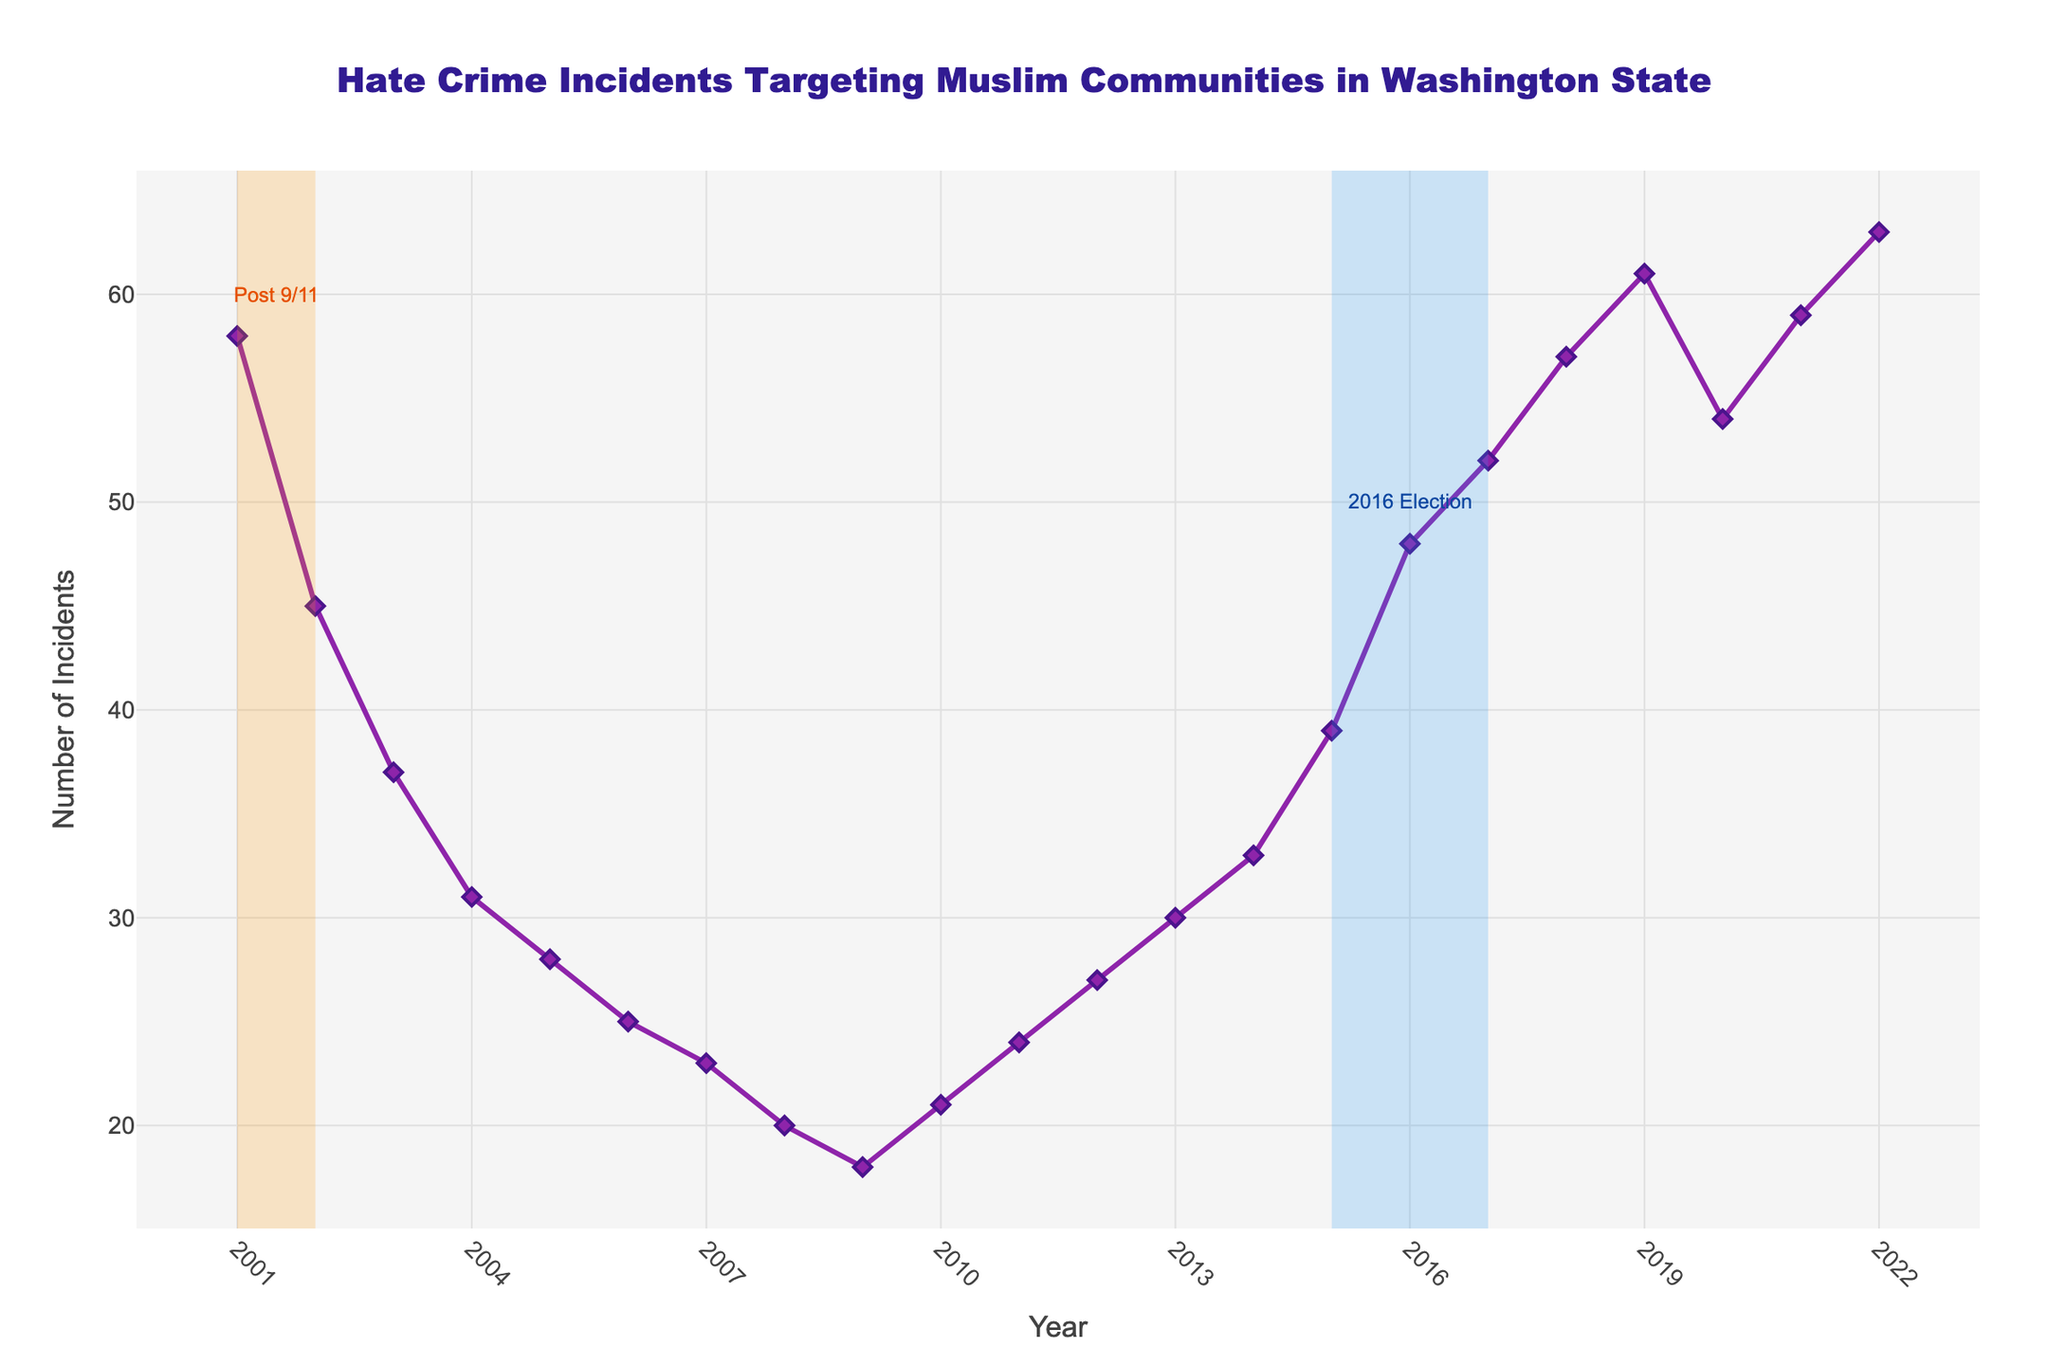Which year had the highest number of hate crime incidents targeting Muslim communities in Washington State? The highest number of hate crime incidents can be found by locating the peak point on the line chart. The peak is at the year 2022 with 63 incidents.
Answer: 2022 How did the number of hate crime incidents change from 2001 to 2003? From 2001 to 2003, the number of incidents decreased. Specifically, it went from 58 in 2001 to 45 in 2002, and then to 37 in 2003.
Answer: Decreased What was the trend in hate crime incidents targeting Muslim communities between 2005 and 2010? Reviewing the chart from 2005 to 2010, the incidents generally showed a decreasing trend initially from 28 in 2005 to 18 in 2009 but increased slightly in 2010 to 21.
Answer: Decreasing then Increasing Which two periods were highlighted by shaded areas, and what incidents do they represent? The two shaded areas are from 2001 to 2002 and from 2015 to 2017. These represent the post 9/11 period and the 2016 Election period respectively.
Answer: 2001-2002, 2015-2017 What was the overall trend in hate crime incidents from 2001 to 2022? Observed from the chart, the overall trend from 2001 to 2022 started with a decrease in incidents up to around 2009, then a gradual increase with a notable spike in recent years.
Answer: Decreasing then Increasing In which year after 2010 did hate crime incidents first exceed 50? By observing the chart, the first year after 2010 when incidents exceed 50 is 2017.
Answer: 2017 How many more hate crime incidents were there in 2022 compared to 2005? To find the difference, subtract the number of incidents in 2005 (28) from the number in 2022 (63). This gives a difference of 35.
Answer: 35 Between 2015 and 2016, did the number of hate crime incidents increase by more or less than 10? Compare the number of incidents in 2015 (39) and 2016 (48). The increase is 48 - 39 = 9, which is less than 10.
Answer: Less What period had a greater increase in hate crime incidents, 2003 to 2005 or 2018 to 2020? First, calculate the increase from 2003 to 2005: 28 - 37 = -9 (a decrease). Then, calculate the change from 2018 to 2020: 54 - 57 = -3 (a decrease smaller in magnitude).
Answer: 2018-2020 